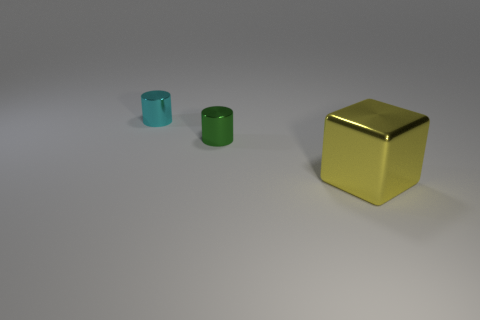The metallic object that is to the right of the small metallic object in front of the small cylinder behind the green metallic object is what color?
Offer a very short reply. Yellow. There is a shiny thing in front of the tiny metal object that is on the right side of the tiny cyan thing; what is its shape?
Your answer should be compact. Cube. Is the number of cyan objects that are to the left of the large yellow shiny cube greater than the number of blue objects?
Your response must be concise. Yes. Is the shape of the metal thing left of the tiny green cylinder the same as  the large yellow object?
Make the answer very short. No. Are there any green metallic objects that have the same shape as the large yellow object?
Keep it short and to the point. No. How many things are either large things that are on the right side of the small cyan cylinder or purple balls?
Your response must be concise. 1. Is the number of cyan metallic cylinders greater than the number of small objects?
Your answer should be compact. No. Are there any green cylinders of the same size as the cyan metal cylinder?
Provide a succinct answer. Yes. How many objects are things right of the small cyan cylinder or objects in front of the tiny cyan shiny cylinder?
Provide a short and direct response. 2. The block in front of the small object in front of the small cyan metal cylinder is what color?
Your answer should be very brief. Yellow. 